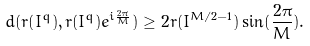Convert formula to latex. <formula><loc_0><loc_0><loc_500><loc_500>d ( r ( I ^ { q } ) , r ( I ^ { q } ) e ^ { i \frac { 2 \pi } { M } } ) \geq 2 r ( I ^ { M / 2 - 1 } ) \sin ( \frac { 2 \pi } { M } ) .</formula> 